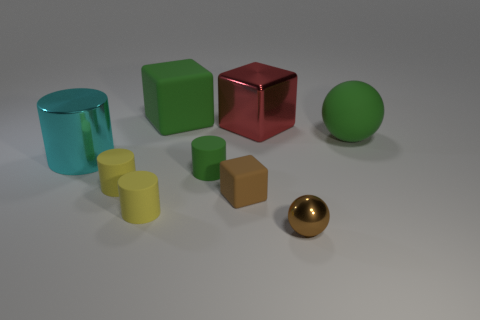Subtract all brown blocks. How many blocks are left? 2 Subtract all brown blocks. How many yellow cylinders are left? 2 Subtract all brown cubes. How many cubes are left? 2 Subtract 1 spheres. How many spheres are left? 1 Subtract all balls. How many objects are left? 7 Subtract all small things. Subtract all gray metal balls. How many objects are left? 4 Add 6 spheres. How many spheres are left? 8 Add 3 cyan things. How many cyan things exist? 4 Subtract 0 red cylinders. How many objects are left? 9 Subtract all red blocks. Subtract all blue balls. How many blocks are left? 2 